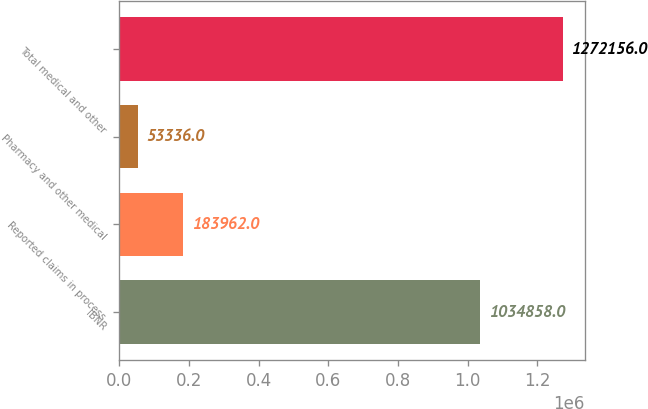Convert chart. <chart><loc_0><loc_0><loc_500><loc_500><bar_chart><fcel>IBNR<fcel>Reported claims in process<fcel>Pharmacy and other medical<fcel>Total medical and other<nl><fcel>1.03486e+06<fcel>183962<fcel>53336<fcel>1.27216e+06<nl></chart> 